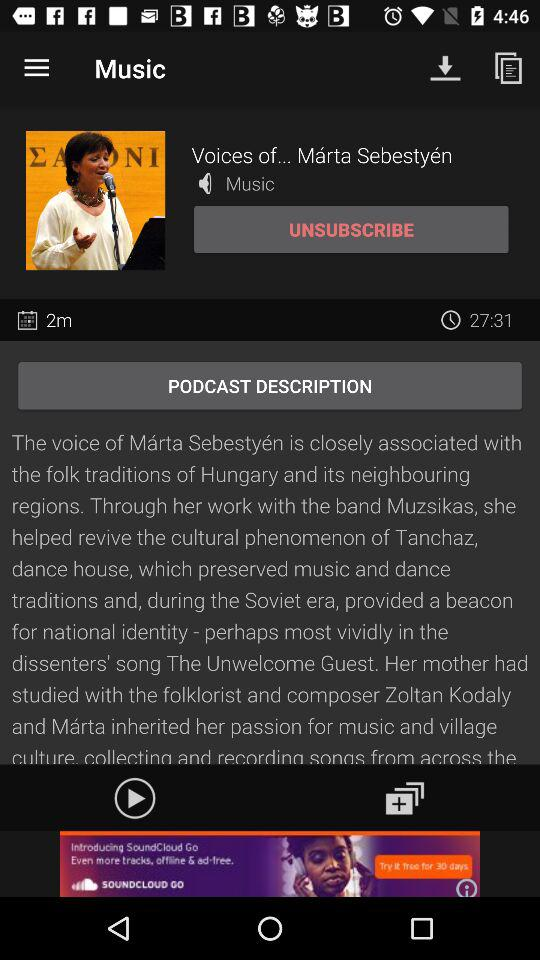What is the title of the podcast? The title of the podcast is "Voices of...". 